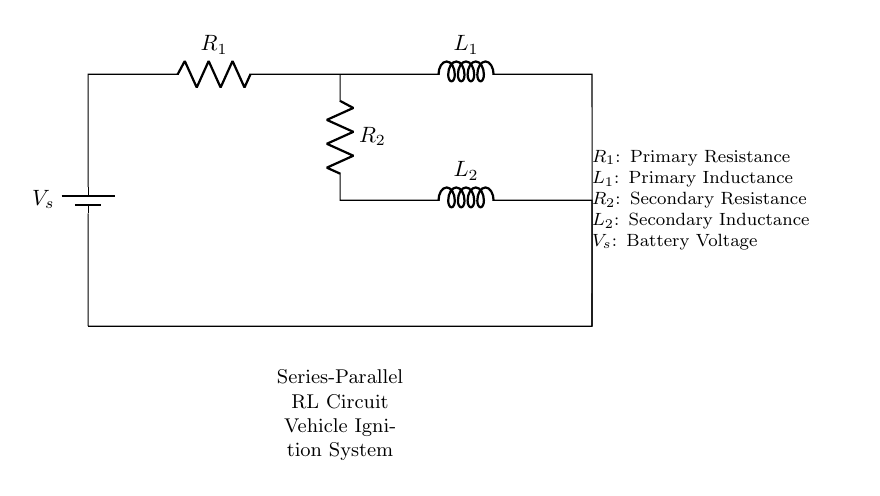What is the total number of resistors in this circuit? The circuit diagram shows two resistors: R1 and R2, which are both explicitly labeled. Therefore, by counting the labeled components, we find a total of two resistors.
Answer: 2 What is the configuration of R1 and L1? R1 and L1 are connected in series, as evidenced by the line connecting R1 to L1 without any branching. In a series configuration, components share the same current, confirming their arrangement in this circuit.
Answer: Series What is the role of L2 in this circuit? L2 functions as an inductor in the secondary circuit, shown below L2 and connected in series with R2. This indicates its purpose in managing current flow and energy storage in the secondary winding of the ignition system.
Answer: Inductor What is the total voltage supplied by the battery? The circuit specifies the battery voltage as V_s, which represents the total voltage supplied to both the series and parallel components connected in the circuit. Therefore, the total voltage supplied by the battery is just V_s.
Answer: V_s What type of circuit is represented by the full assembly of components? The arrangement of components shows it is a series-parallel RL circuit. This circuit type is characterized by the combination of series and parallel connections of resistors and inductors, indicating multiple paths for current.
Answer: Series-parallel What happens to the current through L1 when the circuit is first powered? When the circuit first powers on, the current through L1 will initially be zero because inductors resist changes in current. As time progresses, the current will increase according to the inductance of L1, following the inductive time constant.
Answer: Zero 